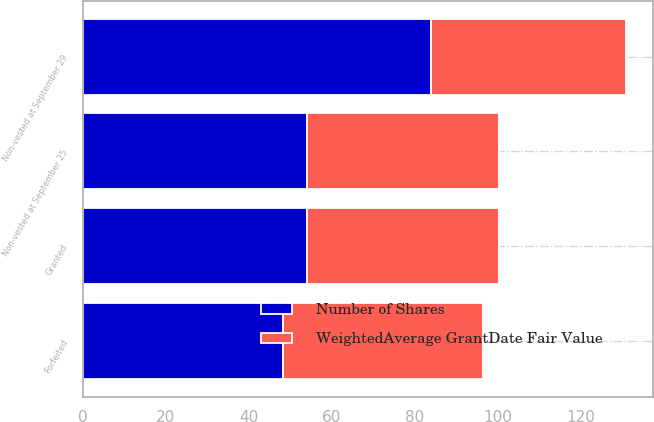Convert chart. <chart><loc_0><loc_0><loc_500><loc_500><stacked_bar_chart><ecel><fcel>Granted<fcel>Non-vested at September 25<fcel>Forfeited<fcel>Non-vested at September 29<nl><fcel>Number of Shares<fcel>54<fcel>54<fcel>48.3<fcel>84<nl><fcel>WeightedAverage GrantDate Fair Value<fcel>46.38<fcel>46.38<fcel>48.3<fcel>47.06<nl></chart> 